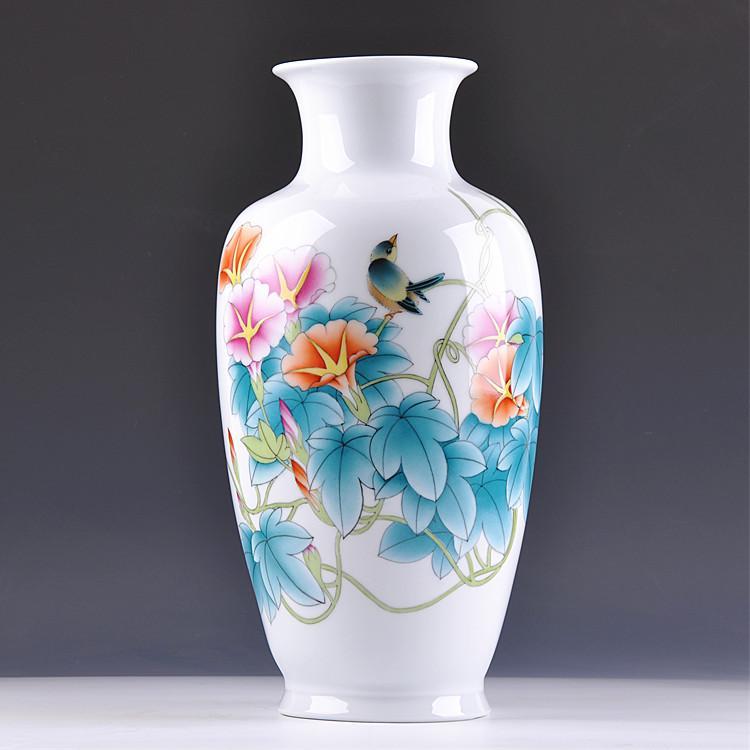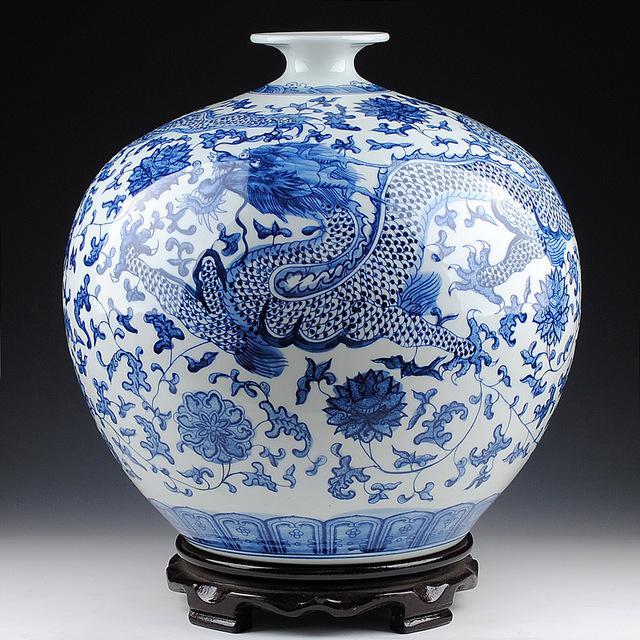The first image is the image on the left, the second image is the image on the right. For the images displayed, is the sentence "One vase features a sky-blue background decorated with flowers and flying creatures." factually correct? Answer yes or no. No. 